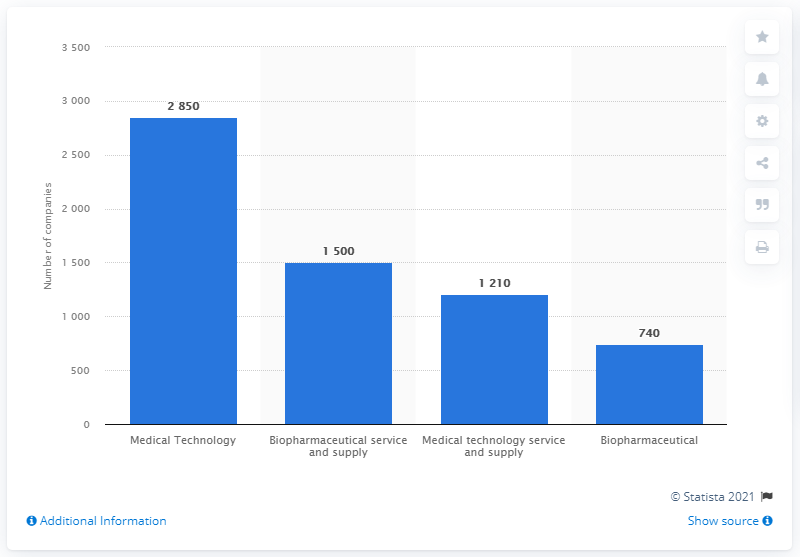List a handful of essential elements in this visual. The biopharmaceutical sector was the second largest in terms of the number of life science companies in the UK in 2019, according to recent data. 